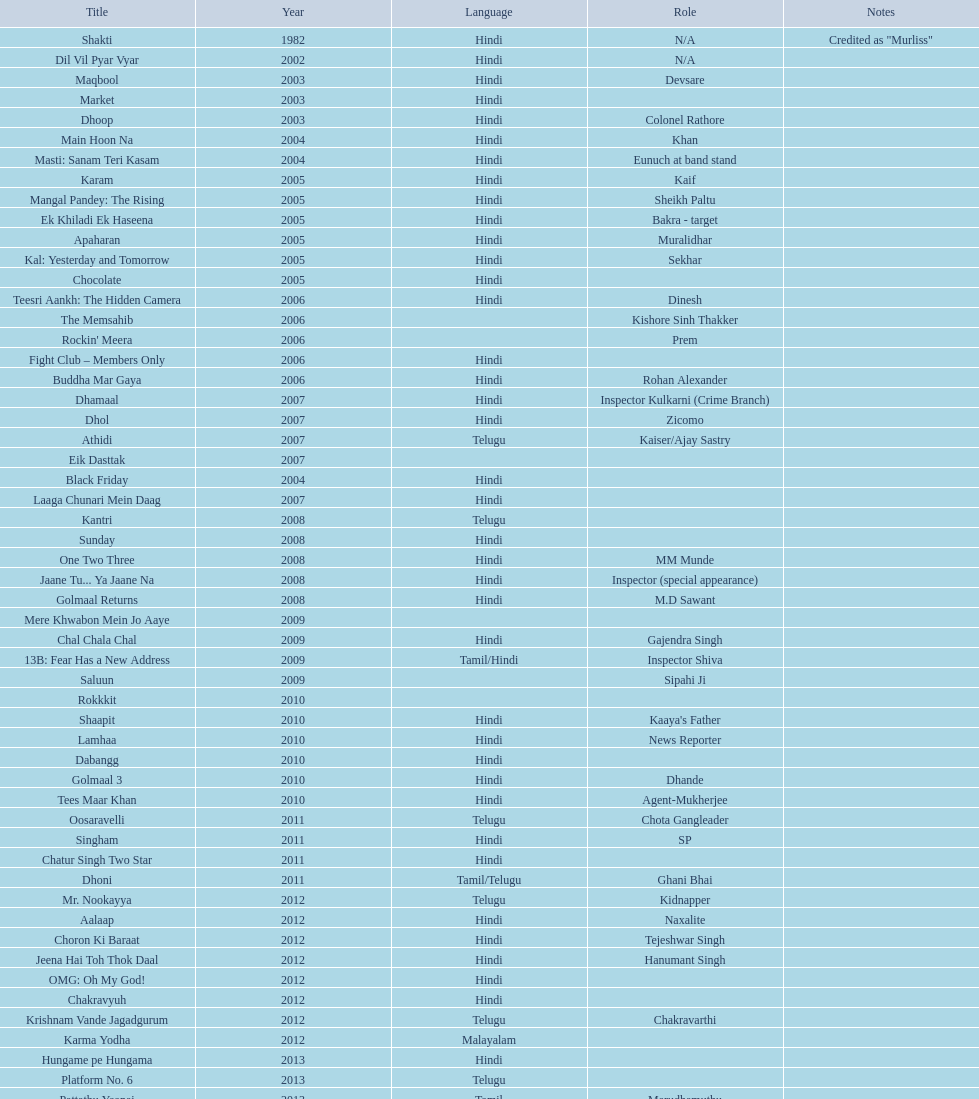What title precedes dhol in 2007? Dhamaal. 